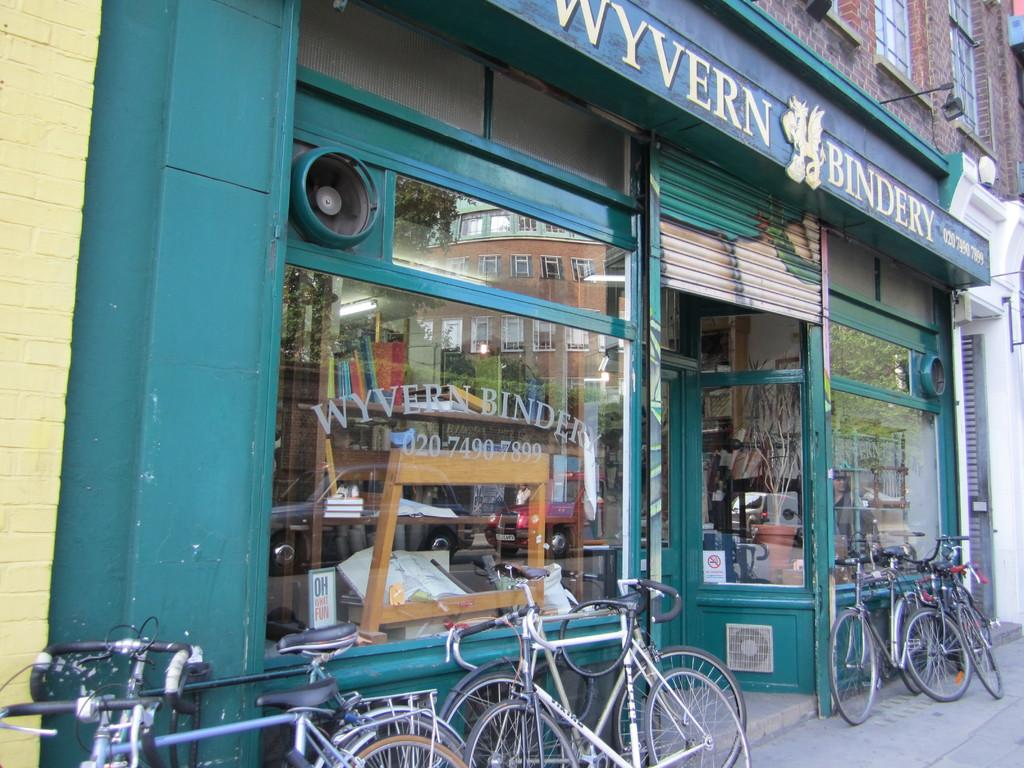Provide a one-sentence caption for the provided image. The exterior of a bindery shop in Wyvern has several bycycles resting against it. 